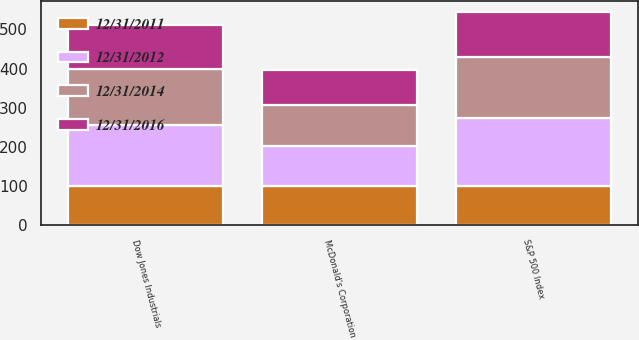Convert chart to OTSL. <chart><loc_0><loc_0><loc_500><loc_500><stacked_bar_chart><ecel><fcel>McDonald's Corporation<fcel>S&P 500 Index<fcel>Dow Jones Industrials<nl><fcel>12/31/2011<fcel>100<fcel>100<fcel>100<nl><fcel>12/31/2016<fcel>91<fcel>116<fcel>110<nl><fcel>12/31/2014<fcel>103<fcel>154<fcel>143<nl><fcel>12/31/2012<fcel>103<fcel>175<fcel>157<nl></chart> 